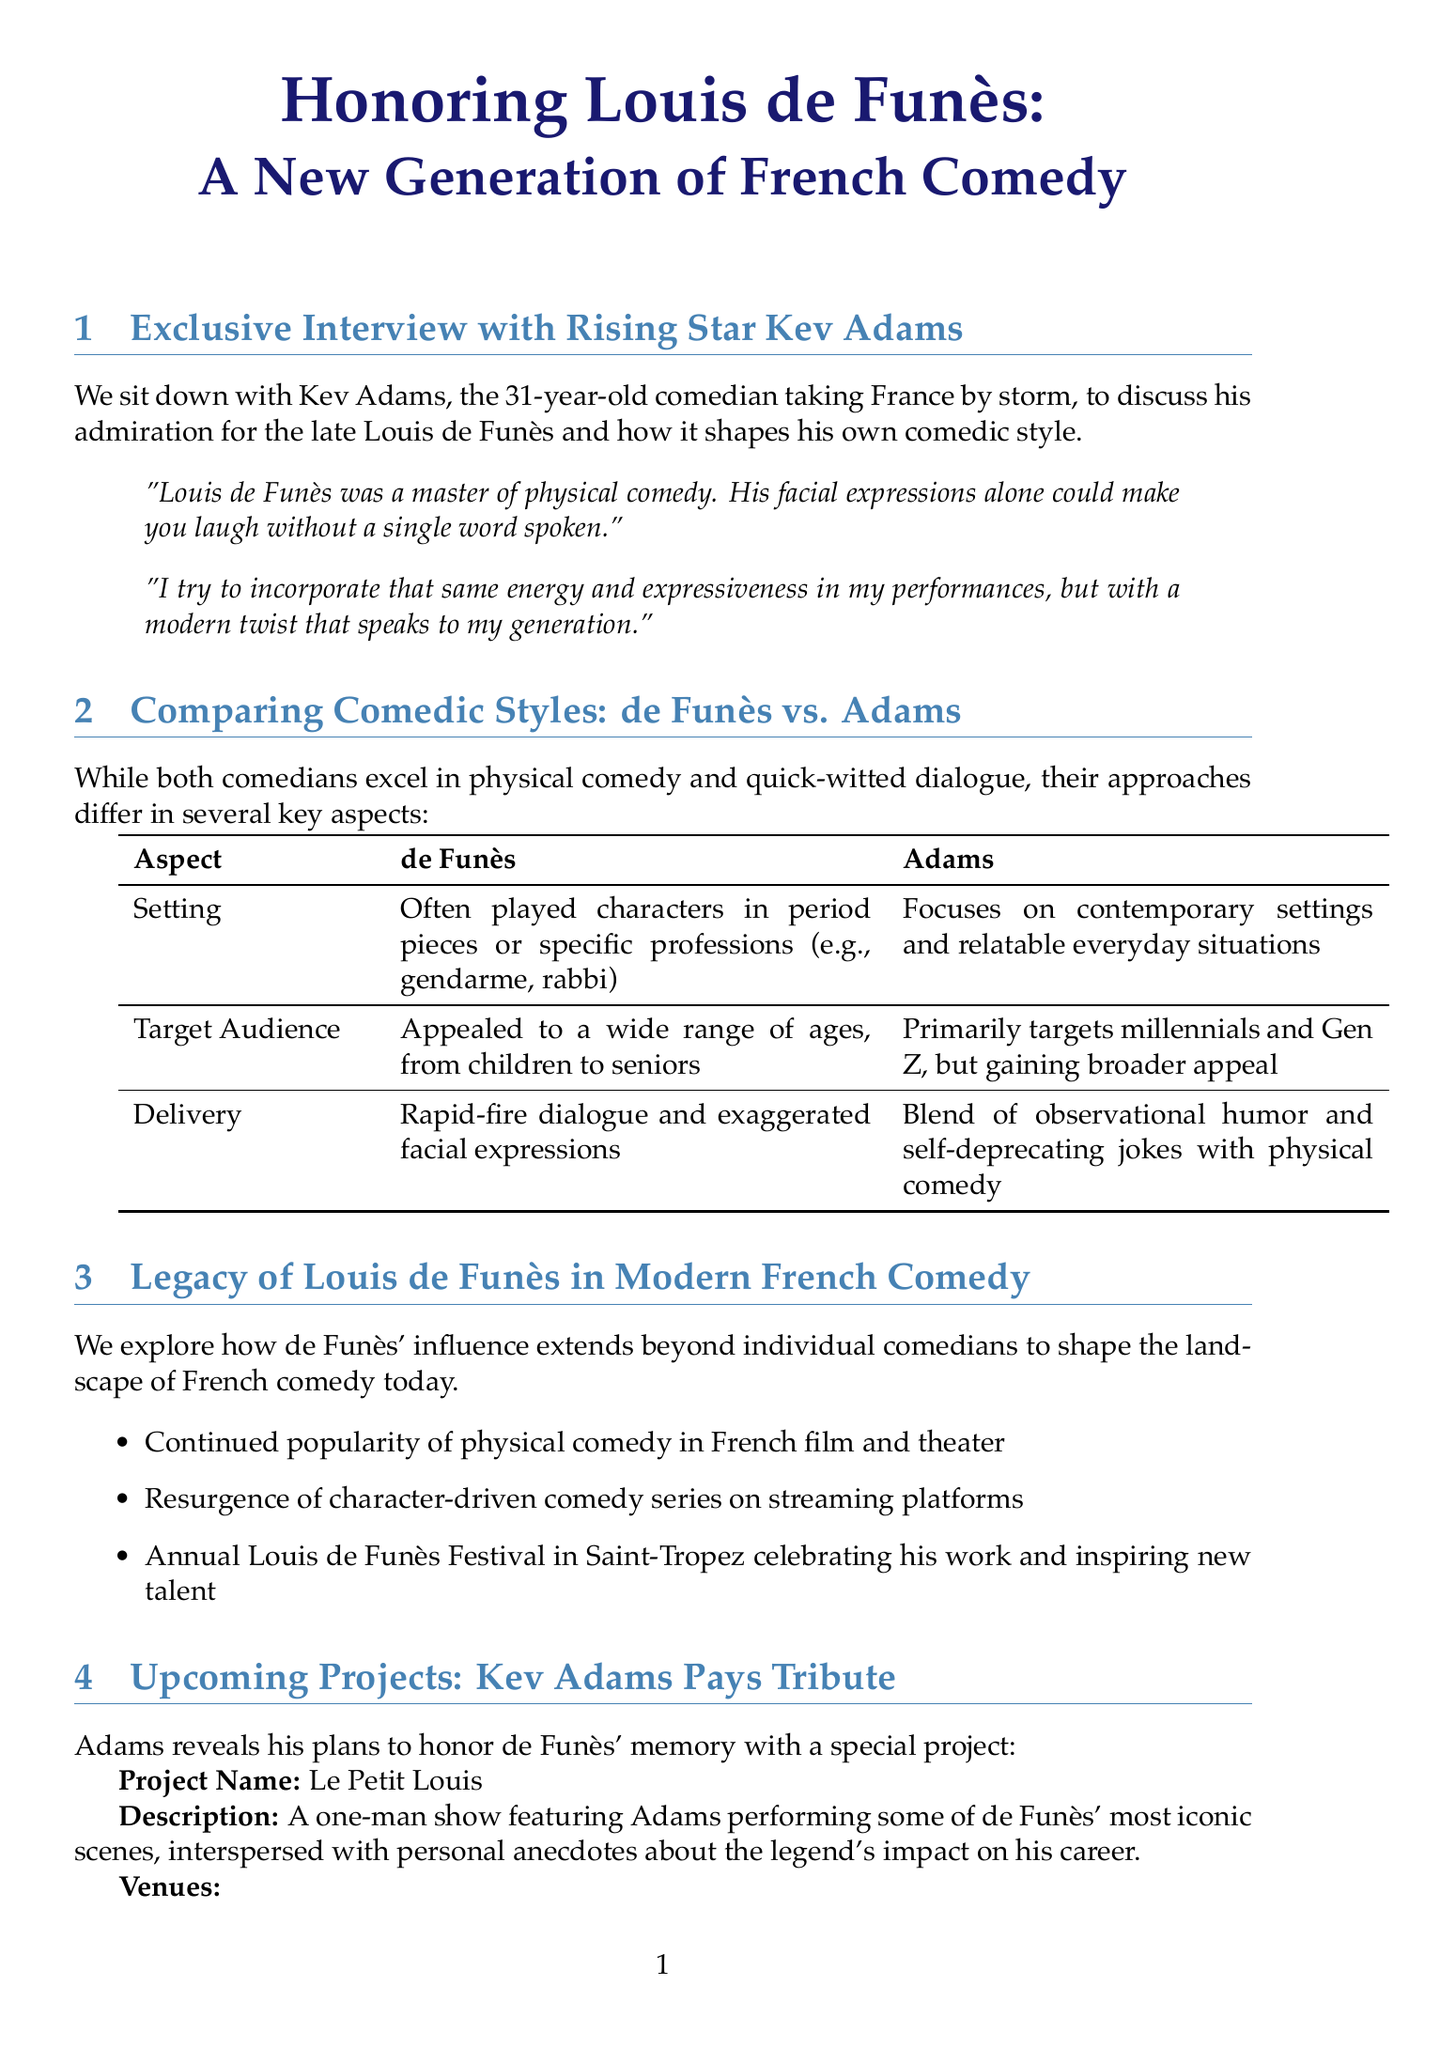What is the title of the newsletter? The title is mentioned at the beginning and encapsulates the theme of the newsletter.
Answer: Honoring Louis de Funès: A New Generation of French Comedy Who is the rising star being interviewed? The newsletter provides the name of the comedian featured in the exclusive interview section.
Answer: Kev Adams What is the name of Kev Adams' tribute project? The project name is stated clearly in the upcoming projects section.
Answer: Le Petit Louis When is the premiere date of Adams' tribute show? The exact date is provided in the details about the upcoming project.
Answer: September 15, 2023 In what types of settings does Kev Adams focus his comedy? The newsletter describes the contemporary focus of Adams' comedic performances in comparison to de Funès.
Answer: Contemporary settings What age groups did Louis de Funès appeal to? The newsletter states the range of ages that enjoyed de Funès' work, highlighting his broad appeal.
Answer: From children to seniors How does Kev Adams incorporate de Funès' style into his performances? Adams expresses how he adapts de Funès’ comedic energy in his own unique way in the quotes section.
Answer: Modern twist that speaks to my generation What venues will host the tribute show? The newsletter lists the venues where Kev Adams will perform his tribute show.
Answer: Théâtre de la Porte Saint-Martin, Olympia, Palais des Festivals et des Congrès What type of comedy does Louis de Funès master? The document mentions the comedic style for which de Funès is notably recognized.
Answer: Physical comedy 